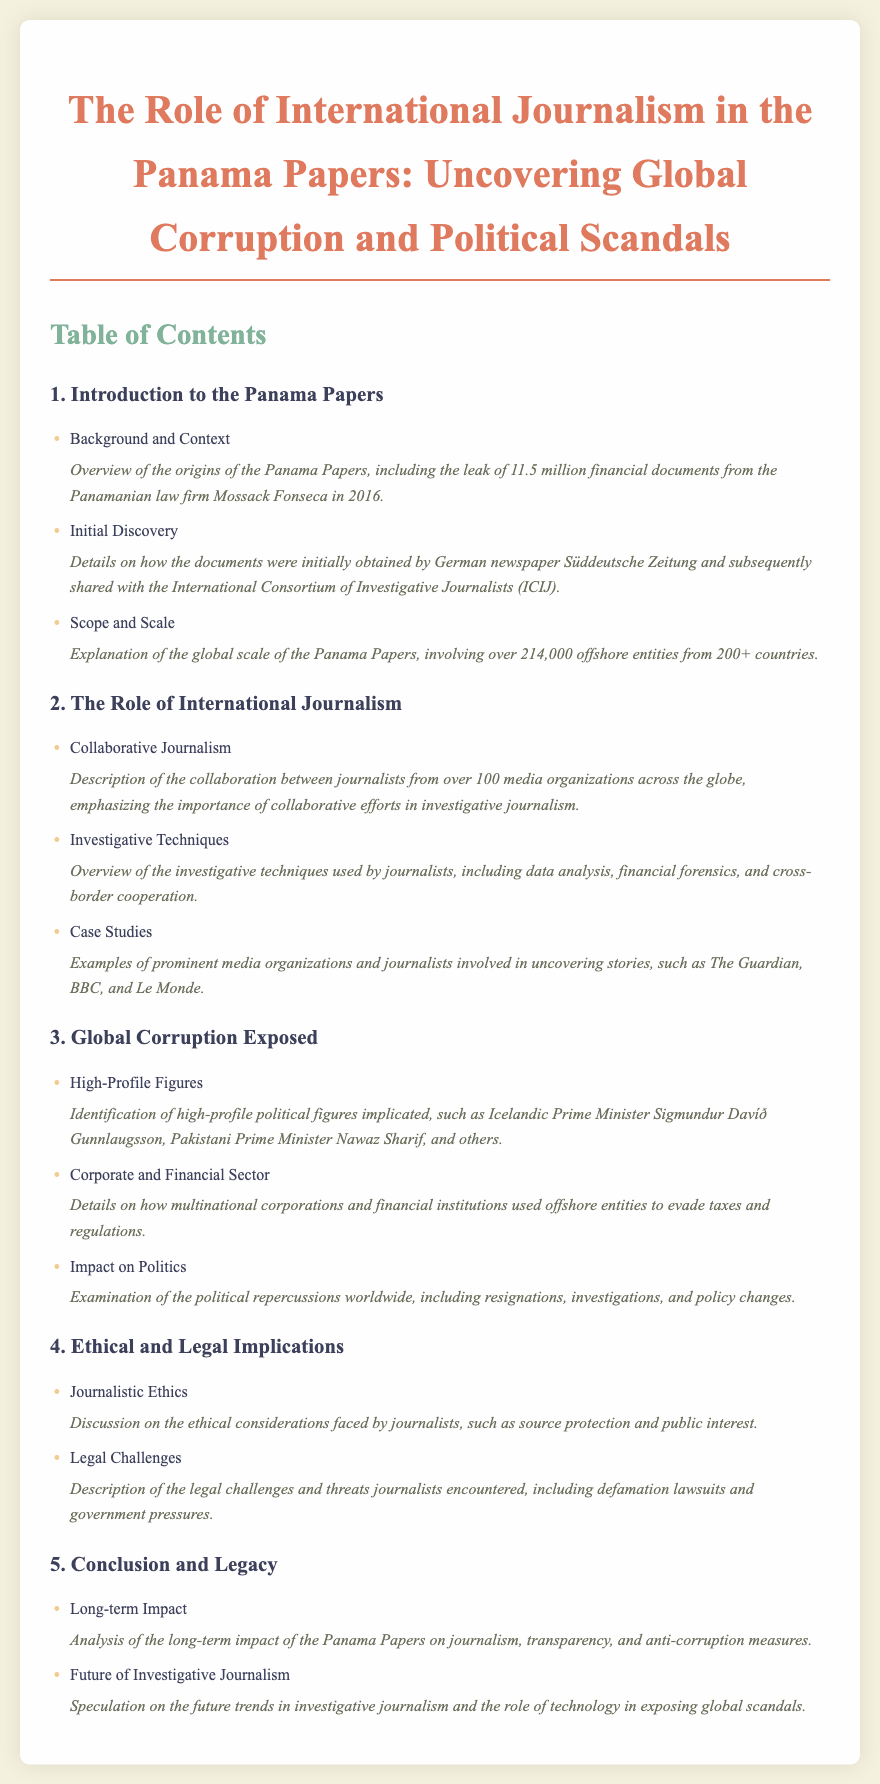What is the background of the Panama Papers? The background includes the origins of the Panama Papers, specifically the leak of 11.5 million financial documents from the Panamanian law firm Mossack Fonseca in 2016.
Answer: Leak of 11.5 million financial documents Who initially discovered the Panama Papers? The initial discovery was made by the German newspaper Süddeutsche Zeitung, which subsequently shared the documents with the International Consortium of Investigative Journalists (ICIJ).
Answer: Süddeutsche Zeitung How many offshore entities were involved in the Panama Papers? The scope includes over 214,000 offshore entities from more than 200 countries.
Answer: Over 214,000 offshore entities Which high-profile political figure from Iceland was implicated? The identification includes Icelandic Prime Minister Sigmundur Davíð Gunnlaugsson among other political figures.
Answer: Sigmundur Davíð Gunnlaugsson What is one ethical consideration faced by journalists? Journalistic ethics includes the consideration of source protection and public interest.
Answer: Source protection What type of journalism emphasized collaboration in the Panama Papers investigation? The document discusses collaborative journalism as a key aspect of the investigation.
Answer: Collaborative journalism What impact did the Panama Papers have on political figures? The impact examines political repercussions, such as resignations and investigations.
Answer: Resignations and investigations What future trend is speculated in the document regarding investigative journalism? Speculation on future trends discusses the role of technology in exposing global scandals.
Answer: Role of technology What section details the legal challenges faced by journalists? The legal challenges are described under the section on Ethical and Legal Implications.
Answer: Ethical and Legal Implications 